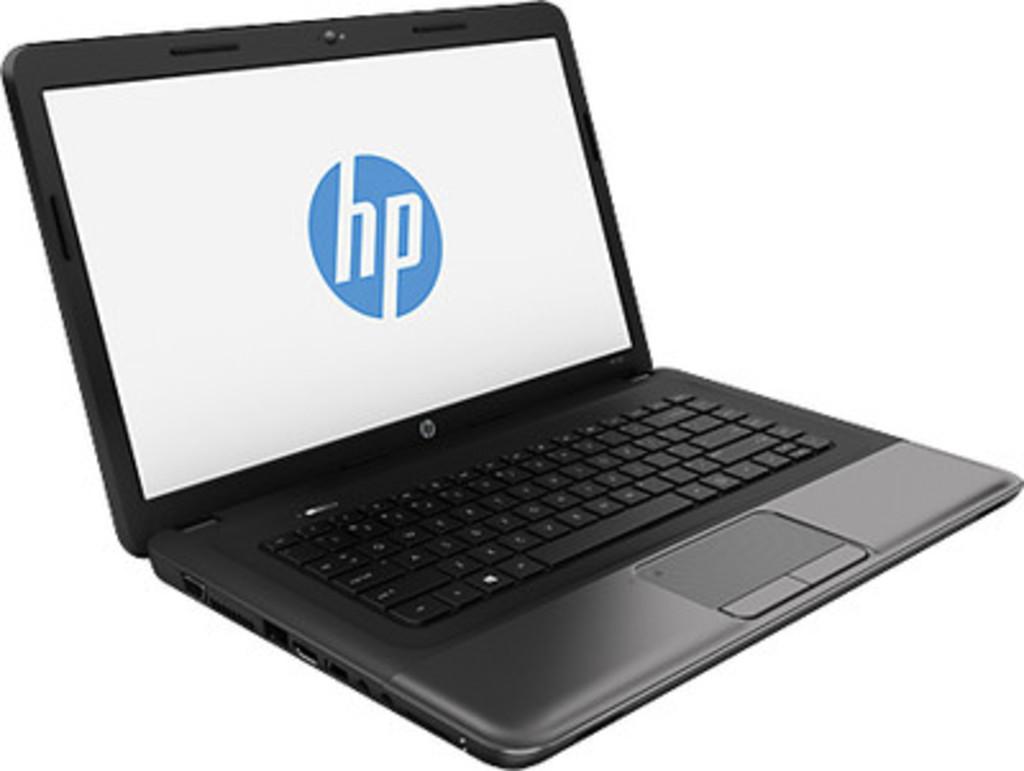Is this an hp computer?
Keep it short and to the point. Yes. What brand is the computer?
Your response must be concise. Hp. 